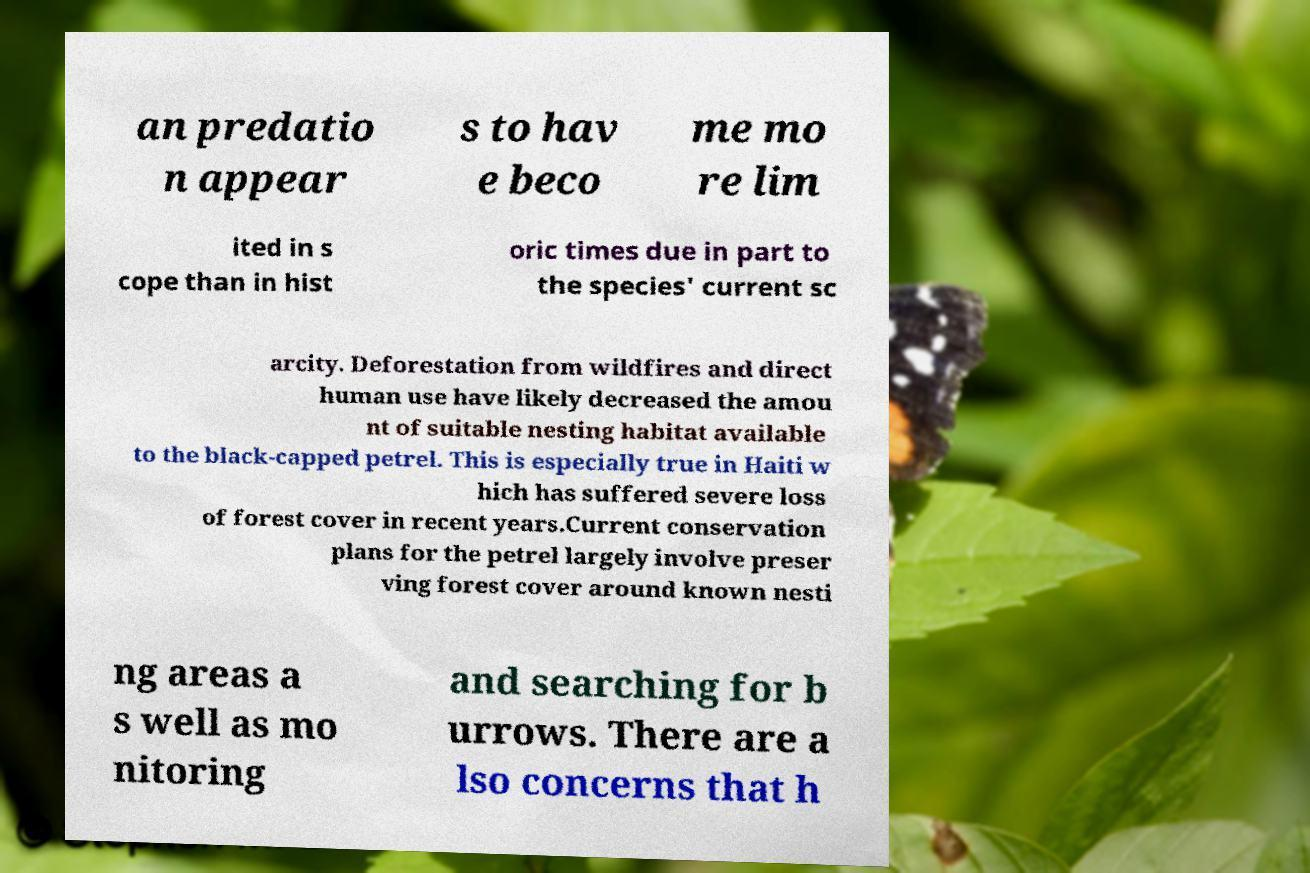Could you assist in decoding the text presented in this image and type it out clearly? an predatio n appear s to hav e beco me mo re lim ited in s cope than in hist oric times due in part to the species' current sc arcity. Deforestation from wildfires and direct human use have likely decreased the amou nt of suitable nesting habitat available to the black-capped petrel. This is especially true in Haiti w hich has suffered severe loss of forest cover in recent years.Current conservation plans for the petrel largely involve preser ving forest cover around known nesti ng areas a s well as mo nitoring and searching for b urrows. There are a lso concerns that h 